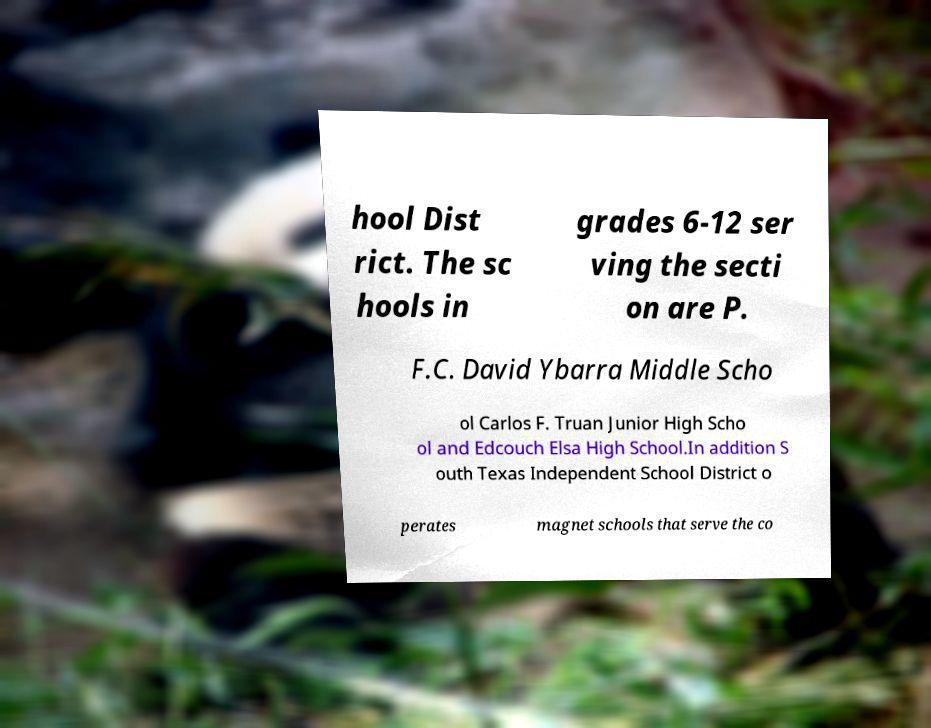Could you extract and type out the text from this image? hool Dist rict. The sc hools in grades 6-12 ser ving the secti on are P. F.C. David Ybarra Middle Scho ol Carlos F. Truan Junior High Scho ol and Edcouch Elsa High School.In addition S outh Texas Independent School District o perates magnet schools that serve the co 